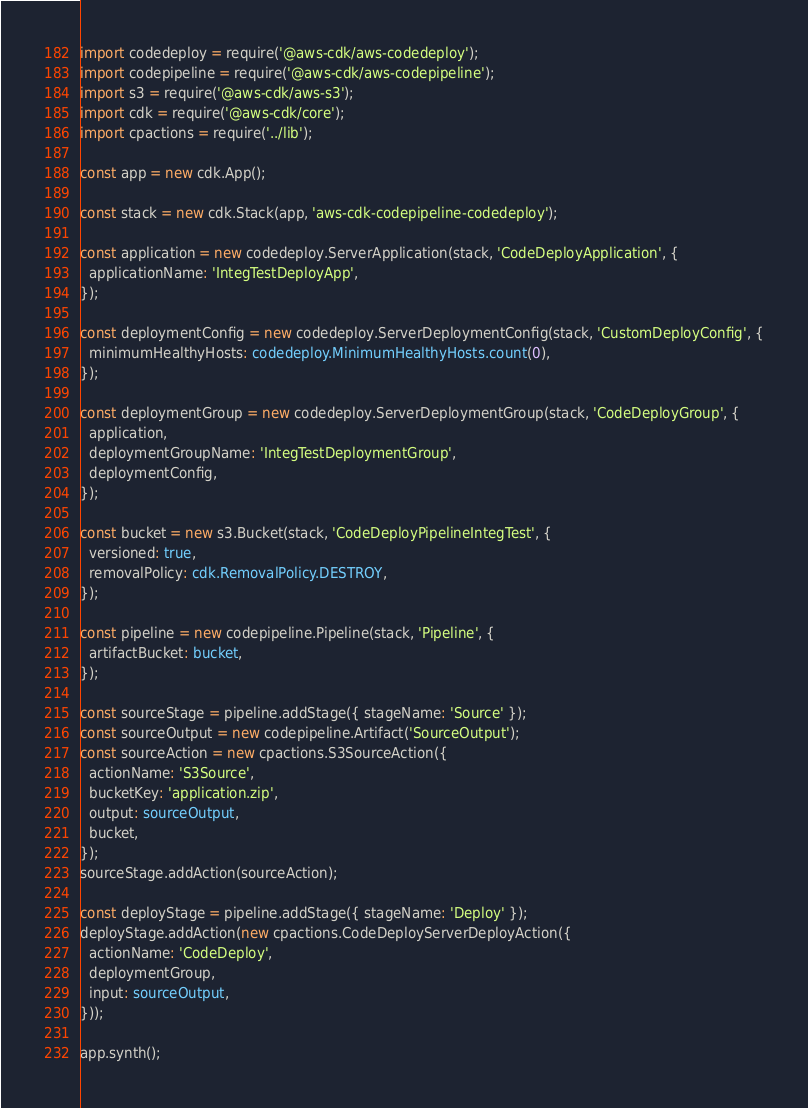Convert code to text. <code><loc_0><loc_0><loc_500><loc_500><_TypeScript_>import codedeploy = require('@aws-cdk/aws-codedeploy');
import codepipeline = require('@aws-cdk/aws-codepipeline');
import s3 = require('@aws-cdk/aws-s3');
import cdk = require('@aws-cdk/core');
import cpactions = require('../lib');

const app = new cdk.App();

const stack = new cdk.Stack(app, 'aws-cdk-codepipeline-codedeploy');

const application = new codedeploy.ServerApplication(stack, 'CodeDeployApplication', {
  applicationName: 'IntegTestDeployApp',
});

const deploymentConfig = new codedeploy.ServerDeploymentConfig(stack, 'CustomDeployConfig', {
  minimumHealthyHosts: codedeploy.MinimumHealthyHosts.count(0),
});

const deploymentGroup = new codedeploy.ServerDeploymentGroup(stack, 'CodeDeployGroup', {
  application,
  deploymentGroupName: 'IntegTestDeploymentGroup',
  deploymentConfig,
});

const bucket = new s3.Bucket(stack, 'CodeDeployPipelineIntegTest', {
  versioned: true,
  removalPolicy: cdk.RemovalPolicy.DESTROY,
});

const pipeline = new codepipeline.Pipeline(stack, 'Pipeline', {
  artifactBucket: bucket,
});

const sourceStage = pipeline.addStage({ stageName: 'Source' });
const sourceOutput = new codepipeline.Artifact('SourceOutput');
const sourceAction = new cpactions.S3SourceAction({
  actionName: 'S3Source',
  bucketKey: 'application.zip',
  output: sourceOutput,
  bucket,
});
sourceStage.addAction(sourceAction);

const deployStage = pipeline.addStage({ stageName: 'Deploy' });
deployStage.addAction(new cpactions.CodeDeployServerDeployAction({
  actionName: 'CodeDeploy',
  deploymentGroup,
  input: sourceOutput,
}));

app.synth();
</code> 